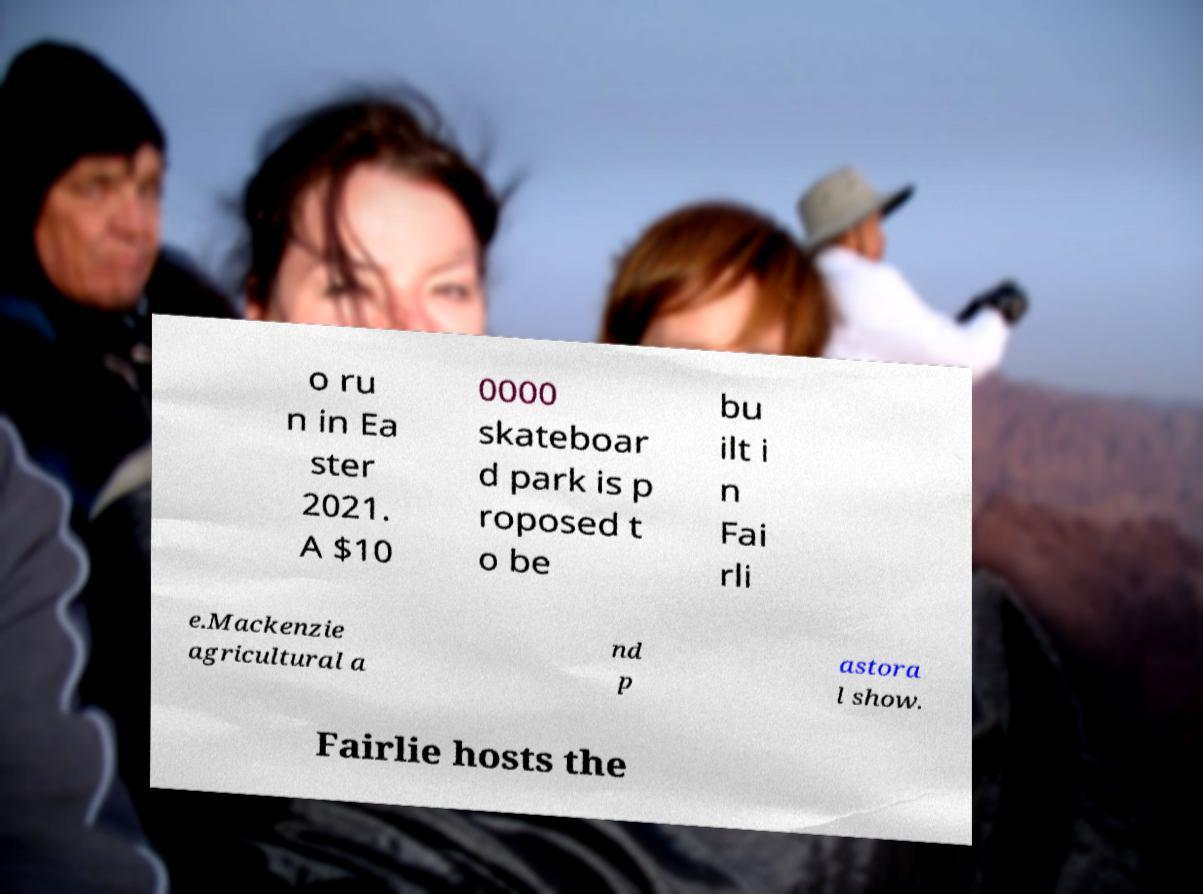Please identify and transcribe the text found in this image. o ru n in Ea ster 2021. A $10 0000 skateboar d park is p roposed t o be bu ilt i n Fai rli e.Mackenzie agricultural a nd p astora l show. Fairlie hosts the 